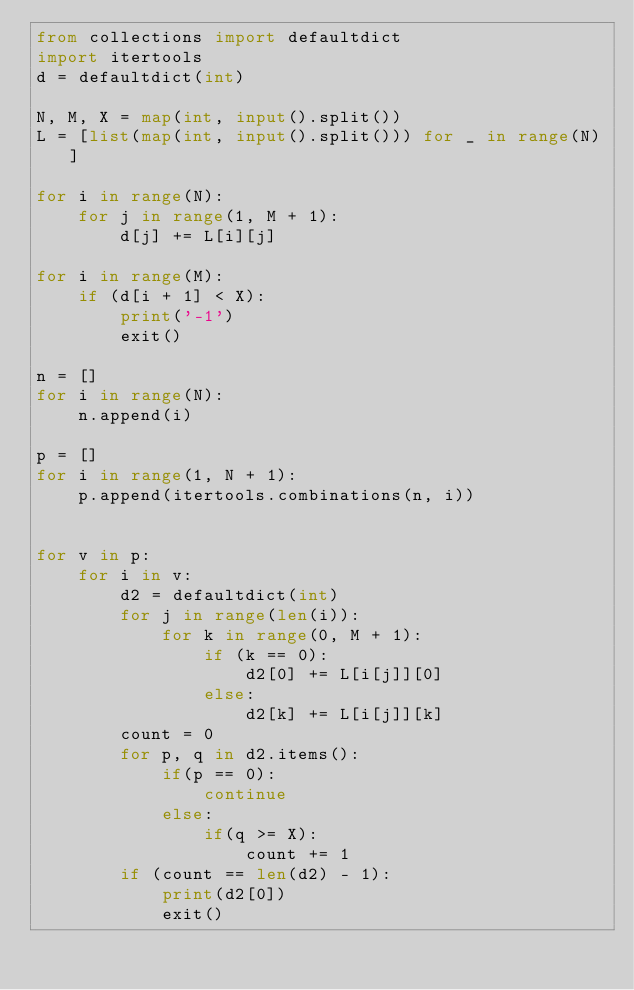<code> <loc_0><loc_0><loc_500><loc_500><_Python_>from collections import defaultdict
import itertools
d = defaultdict(int)

N, M, X = map(int, input().split())
L = [list(map(int, input().split())) for _ in range(N)]

for i in range(N):
    for j in range(1, M + 1):
        d[j] += L[i][j]

for i in range(M):
    if (d[i + 1] < X):
        print('-1')
        exit()

n = []
for i in range(N):
    n.append(i)

p = []
for i in range(1, N + 1):
    p.append(itertools.combinations(n, i))


for v in p:
    for i in v:
        d2 = defaultdict(int)
        for j in range(len(i)):
            for k in range(0, M + 1):
                if (k == 0):
                    d2[0] += L[i[j]][0]
                else:
                    d2[k] += L[i[j]][k]
        count = 0
        for p, q in d2.items():
            if(p == 0):
                continue
            else:
                if(q >= X):
                    count += 1
        if (count == len(d2) - 1):
            print(d2[0])
            exit()</code> 